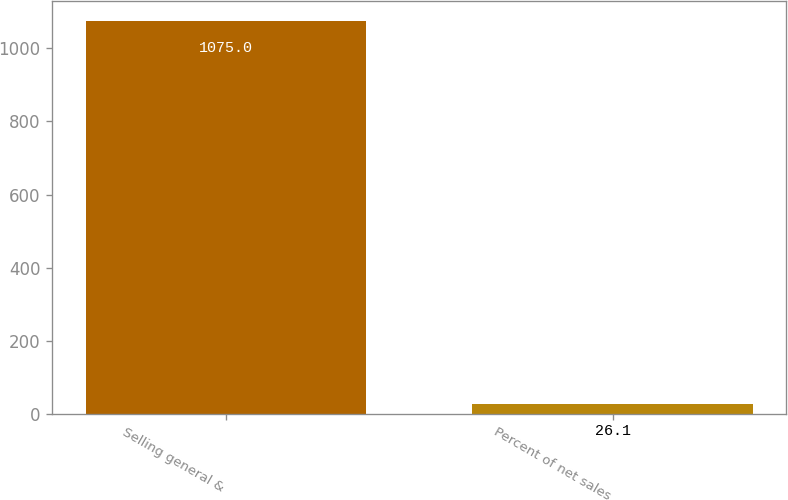Convert chart. <chart><loc_0><loc_0><loc_500><loc_500><bar_chart><fcel>Selling general &<fcel>Percent of net sales<nl><fcel>1075<fcel>26.1<nl></chart> 